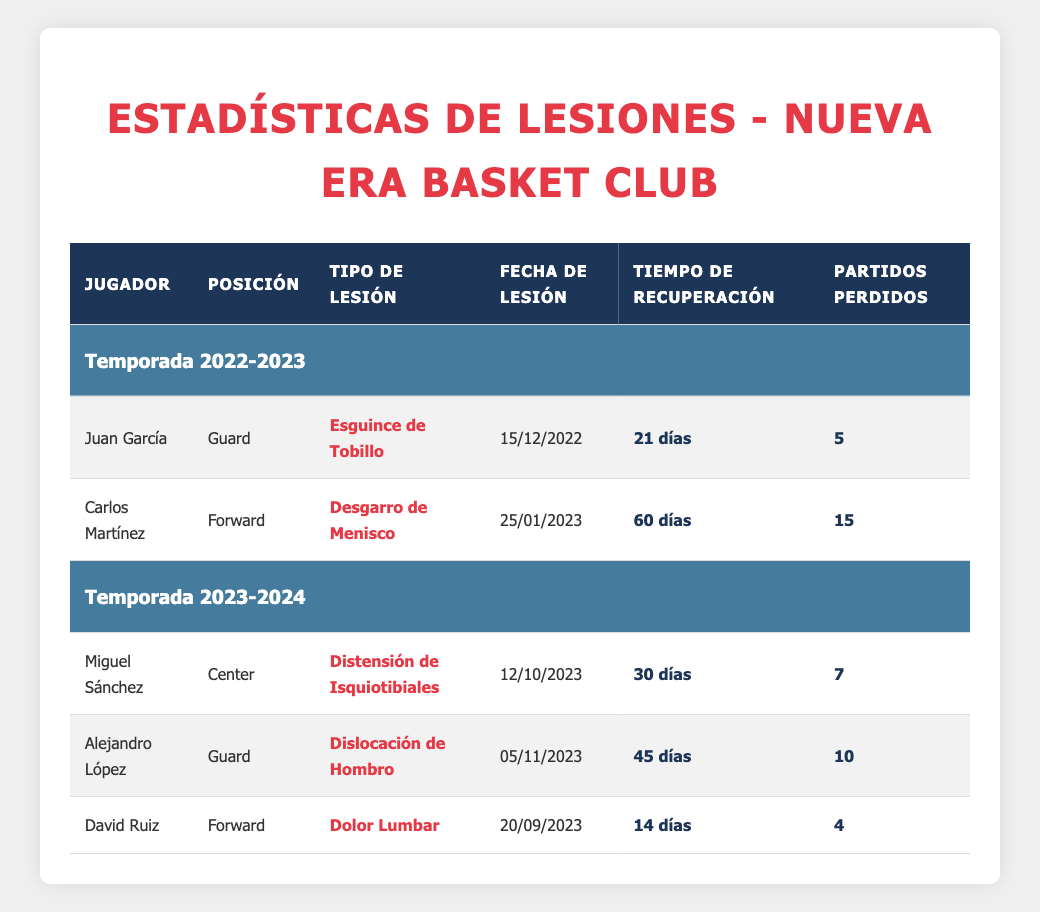What type of injury did Carlos Martínez suffer? The table shows injuries for players, and to find the type of injury for Carlos Martínez, we look under the "Jugador" column to find his name, which is listed next to "Desgarro de Menisco" under "Tipo de Lesión".
Answer: Desgarro de Menisco How many games did Juan García miss due to his injury? In the row for Juan García, the value in the "Partidos Perdidos" column indicates how many games he missed, which is 5.
Answer: 5 What is the average recovery time for the injured players in the 2022-2023 season? Summing the recovery times for that season, we have 21 days for Juan García and 60 days for Carlos Martínez, totaling 81 days. There are 2 players, so we divide by 2: 81/2 = 40.5.
Answer: 40.5 Is Alejandro López's injury type a shoulder dislocation? In the row for Alejandro López, under "Tipo de Lesión", it explicitly states "Dislocación de Hombro", confirming the statement.
Answer: Yes Which player had the longest recovery time and what was it? By examining the recovery times of all players, Carlos Martínez has the longest recovery time of 60 days. We can verify this since no other player has a higher duration recorded in the "Tiempo de Recuperación" column.
Answer: Carlos Martínez, 60 days How many total games were missed by all players in the 2023-2024 season? Checking the "Partidos Perdidos" for each player in the 2023-2024 season: Miguel Sánchez missed 7, Alejandro López missed 10, and David Ruiz missed 4. Adding these together gives 7 + 10 + 4 = 21 games missed in total.
Answer: 21 Did any players recover in less than 30 days in the 2022-2023 season? Reviewing the players from the 2022-2023 season, Juan García had a recovery time of 21 days, which is indeed less than 30 days, confirming that at least one player fits this criterion.
Answer: Yes Which position had the most injuries reported between the two seasons? Counting the injuries by position: Guards (2), Forwards (2), and Centers (1). Both Guards and Forwards had the same number of injuries (2 each), so neither position had more than the other.
Answer: Tie between Guards and Forwards What was the date of Miguel Sánchez's injury? In the row for Miguel Sánchez, the "Fecha de Lesión" is clearly listed, allowing us to directly reference it from the table. This date is 12/10/2023.
Answer: 12/10/2023 